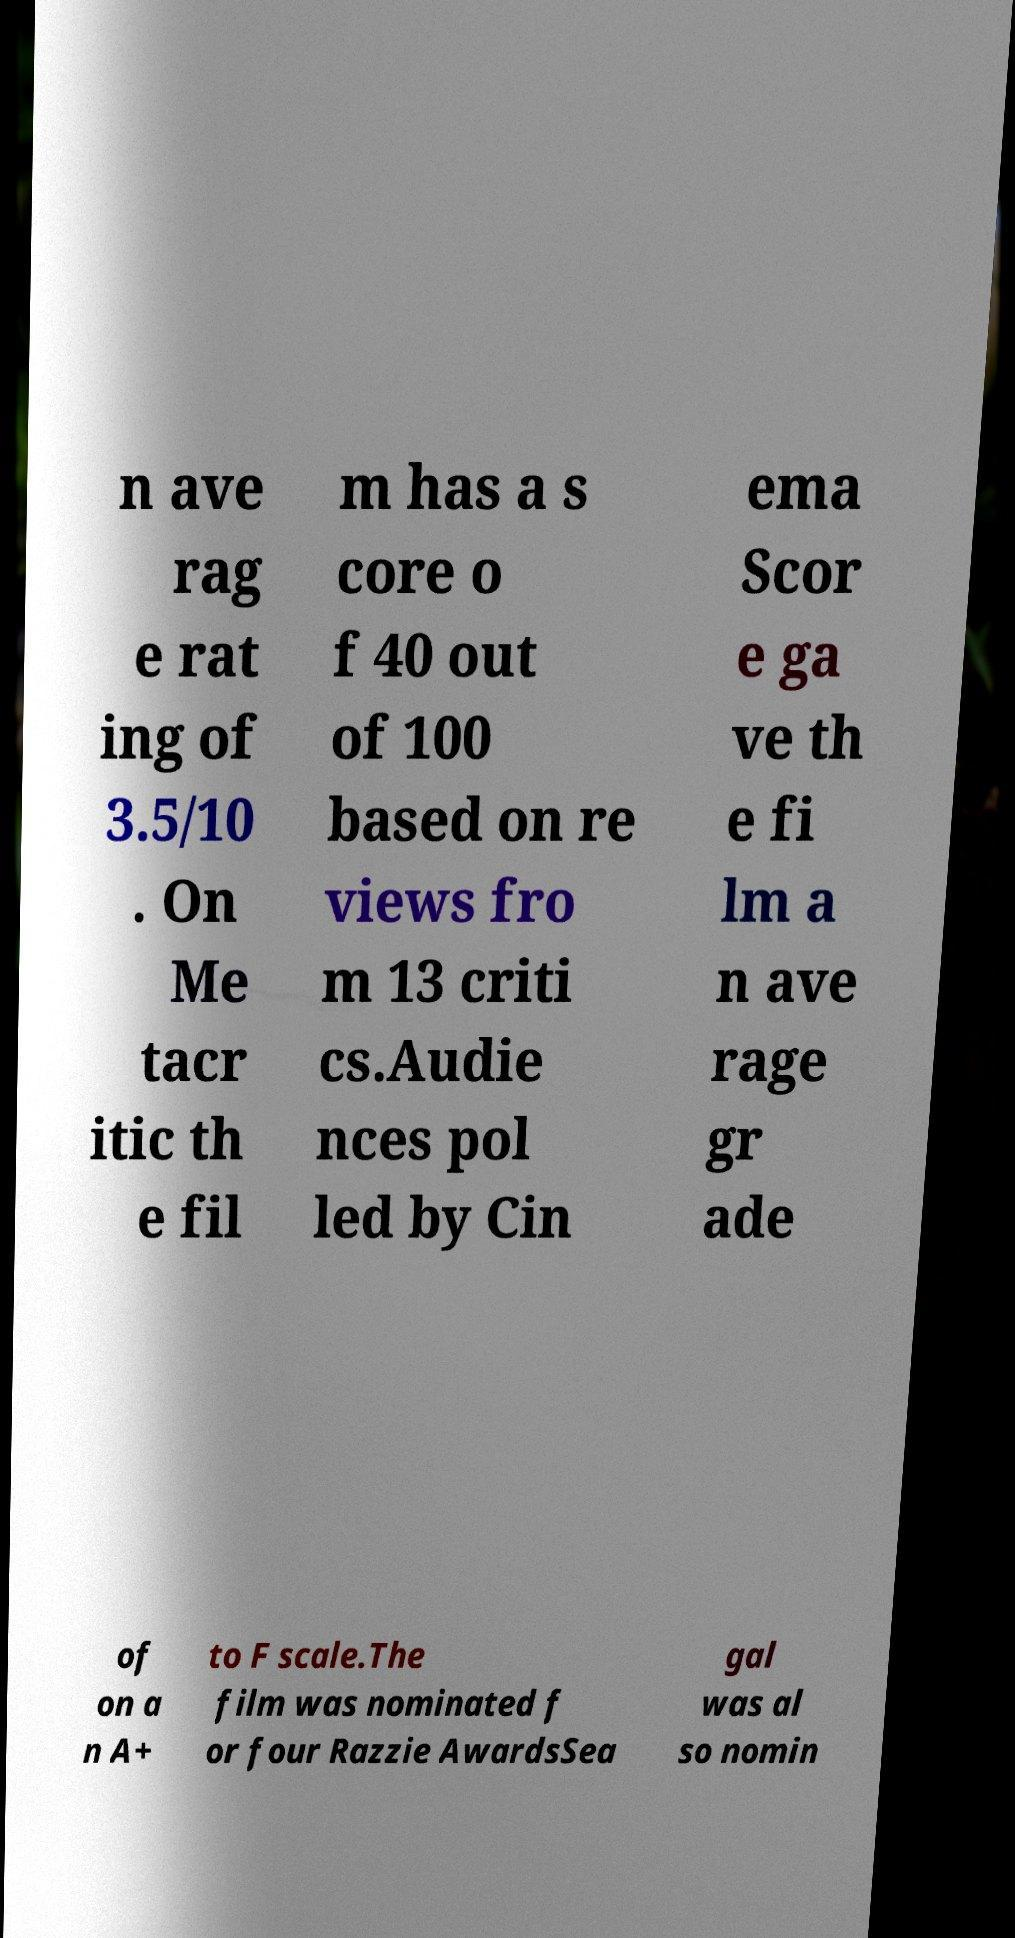Can you accurately transcribe the text from the provided image for me? n ave rag e rat ing of 3.5/10 . On Me tacr itic th e fil m has a s core o f 40 out of 100 based on re views fro m 13 criti cs.Audie nces pol led by Cin ema Scor e ga ve th e fi lm a n ave rage gr ade of on a n A+ to F scale.The film was nominated f or four Razzie AwardsSea gal was al so nomin 